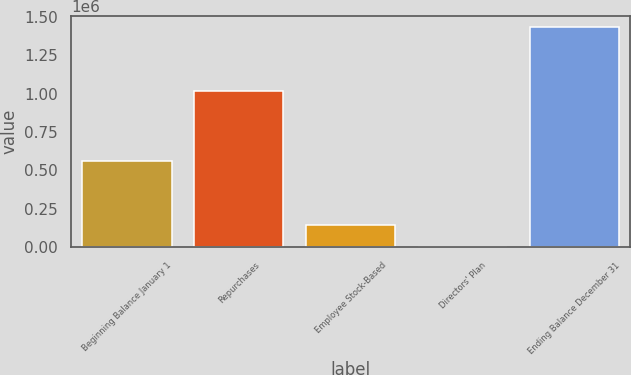Convert chart to OTSL. <chart><loc_0><loc_0><loc_500><loc_500><bar_chart><fcel>Beginning Balance January 1<fcel>Repurchases<fcel>Employee Stock-Based<fcel>Directors' Plan<fcel>Ending Balance December 31<nl><fcel>561152<fcel>1.018e+06<fcel>146877<fcel>252<fcel>1.43202e+06<nl></chart> 